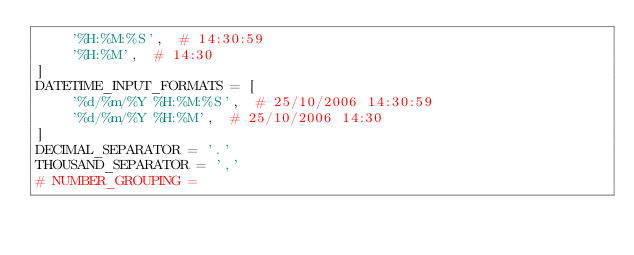<code> <loc_0><loc_0><loc_500><loc_500><_Python_>    '%H:%M:%S',  # 14:30:59
    '%H:%M',  # 14:30
]
DATETIME_INPUT_FORMATS = [
    '%d/%m/%Y %H:%M:%S',  # 25/10/2006 14:30:59
    '%d/%m/%Y %H:%M',  # 25/10/2006 14:30
]
DECIMAL_SEPARATOR = '.'
THOUSAND_SEPARATOR = ','
# NUMBER_GROUPING =
</code> 